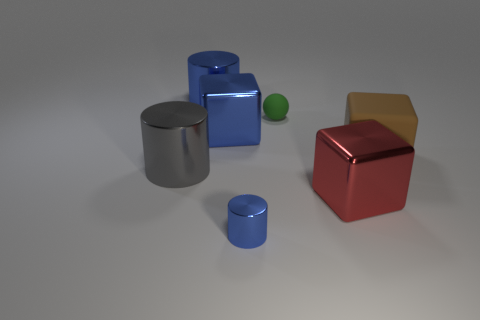Add 2 small metallic objects. How many objects exist? 9 Subtract all blocks. How many objects are left? 4 Add 1 blue blocks. How many blue blocks are left? 2 Add 1 small matte balls. How many small matte balls exist? 2 Subtract 0 gray balls. How many objects are left? 7 Subtract all green matte cubes. Subtract all blue shiny cylinders. How many objects are left? 5 